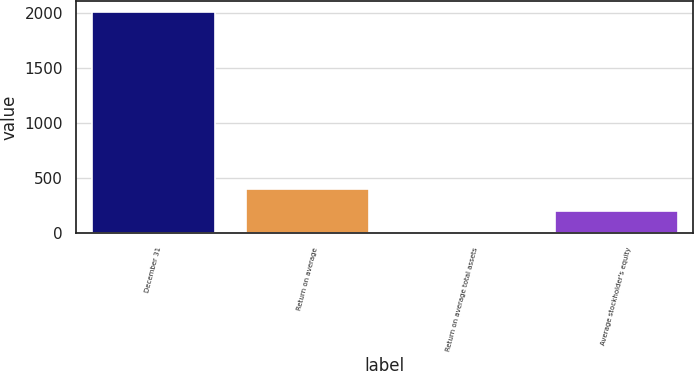<chart> <loc_0><loc_0><loc_500><loc_500><bar_chart><fcel>December 31<fcel>Return on average<fcel>Return on average total assets<fcel>Average stockholder's equity<nl><fcel>2012<fcel>403.13<fcel>0.91<fcel>202.02<nl></chart> 